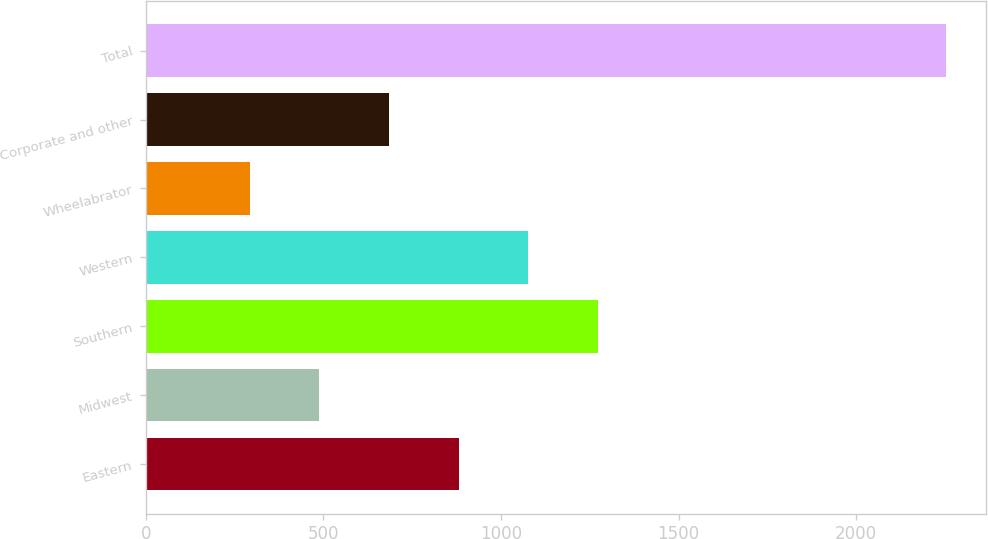<chart> <loc_0><loc_0><loc_500><loc_500><bar_chart><fcel>Eastern<fcel>Midwest<fcel>Southern<fcel>Western<fcel>Wheelabrator<fcel>Corporate and other<fcel>Total<nl><fcel>880.6<fcel>488.2<fcel>1273<fcel>1076.8<fcel>292<fcel>684.4<fcel>2254<nl></chart> 